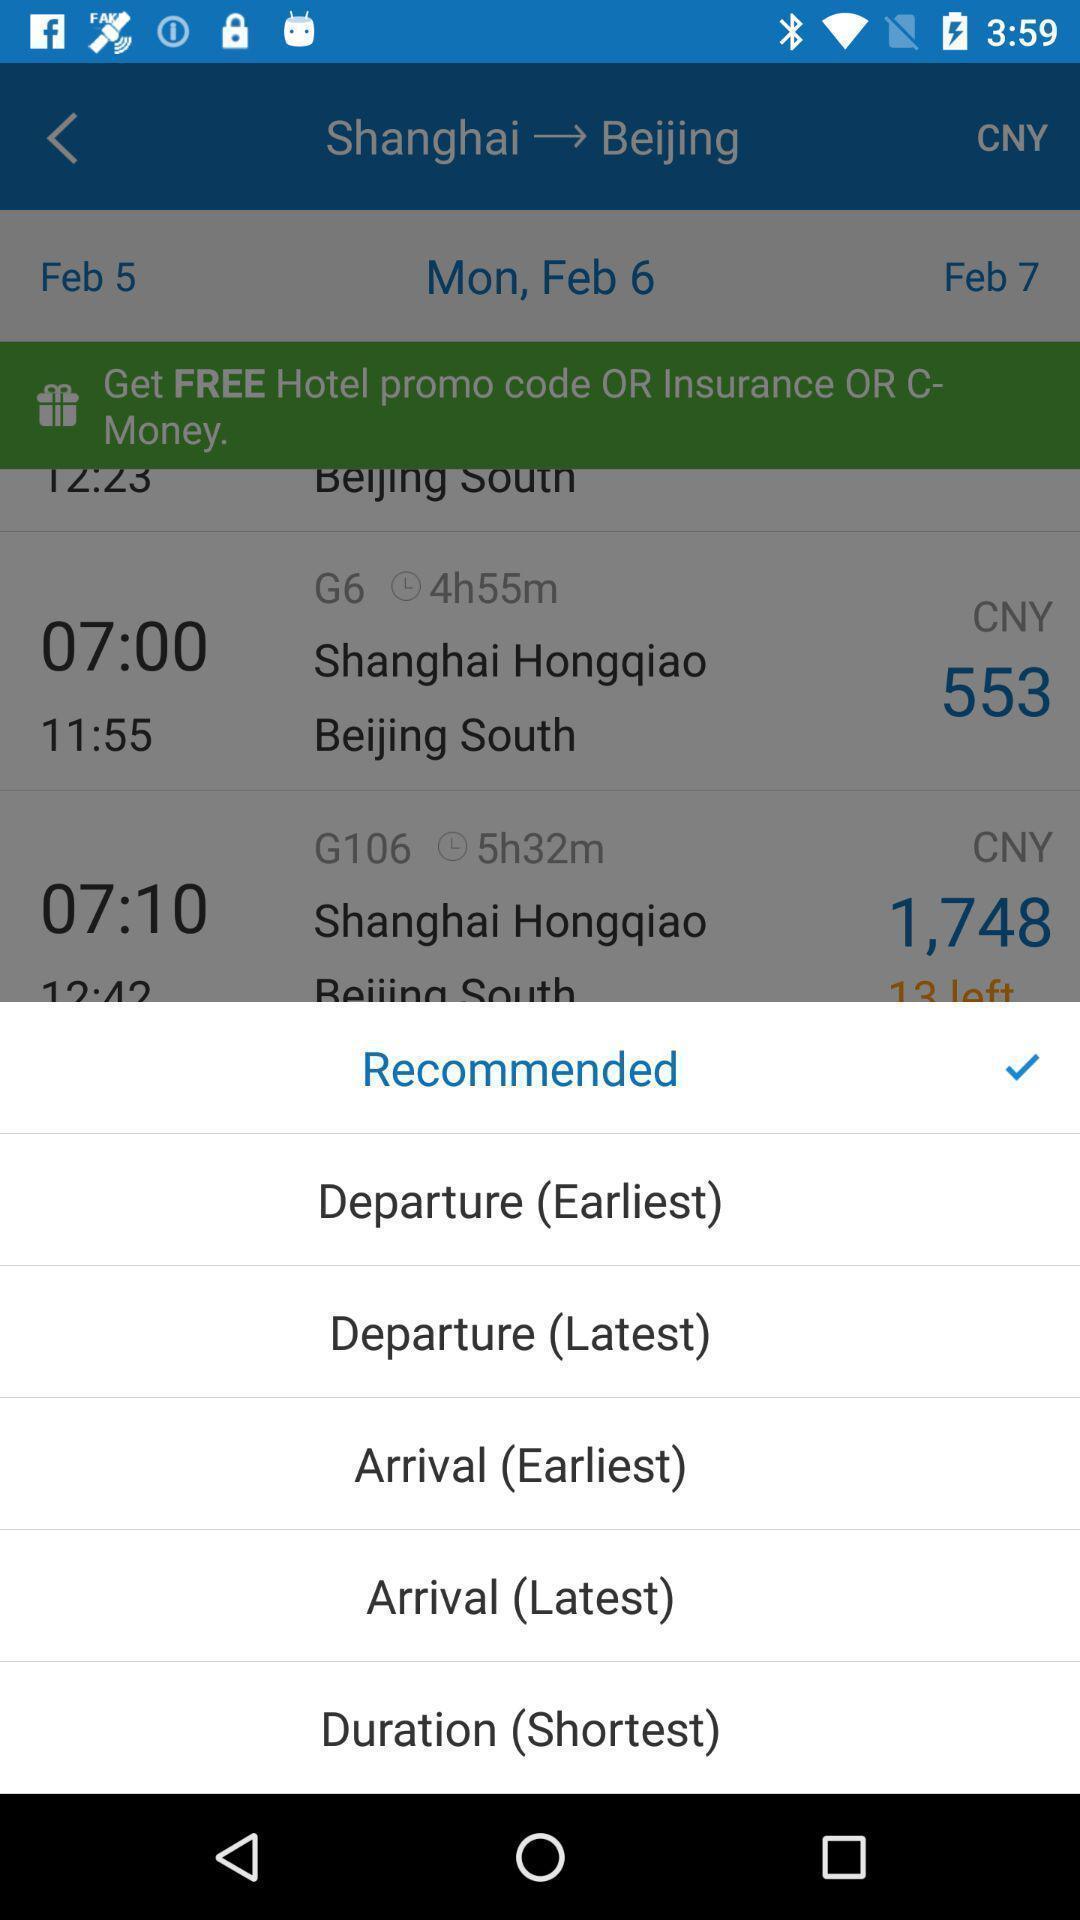Summarize the information in this screenshot. Pop up with options in travel application. 